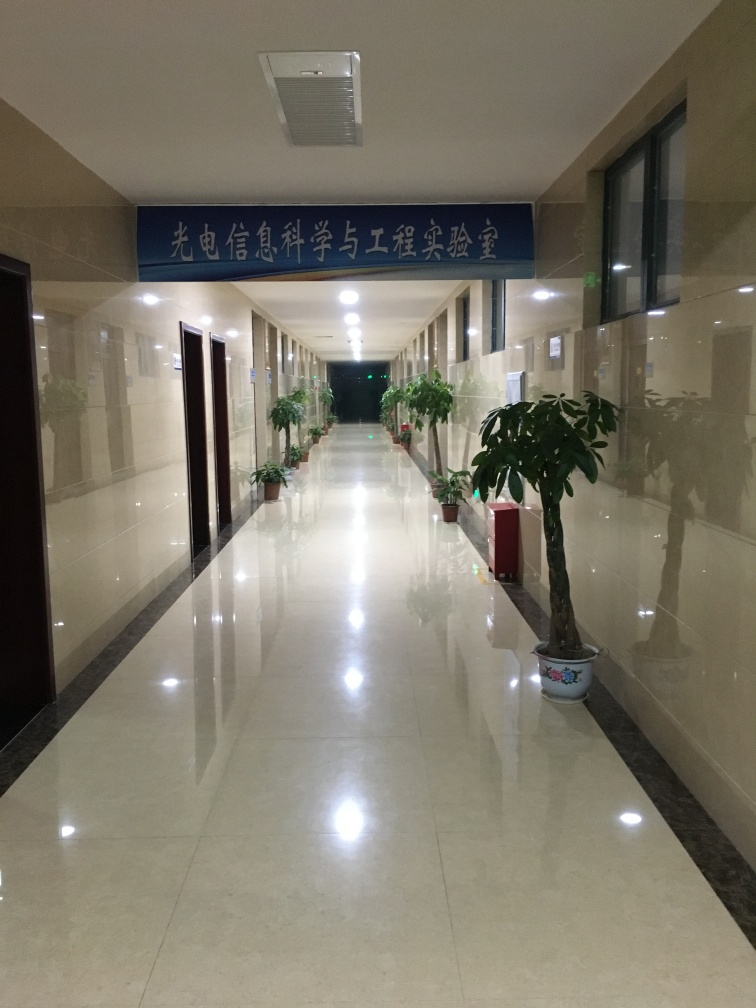What improvements could be made to this space? To enhance the space aesthetically, introducing more decorative elements, varied lighting, and perhaps seating areas could make the hallway feel more welcoming. Offering informational signage or interactive displays could also improve utility for visitors. 